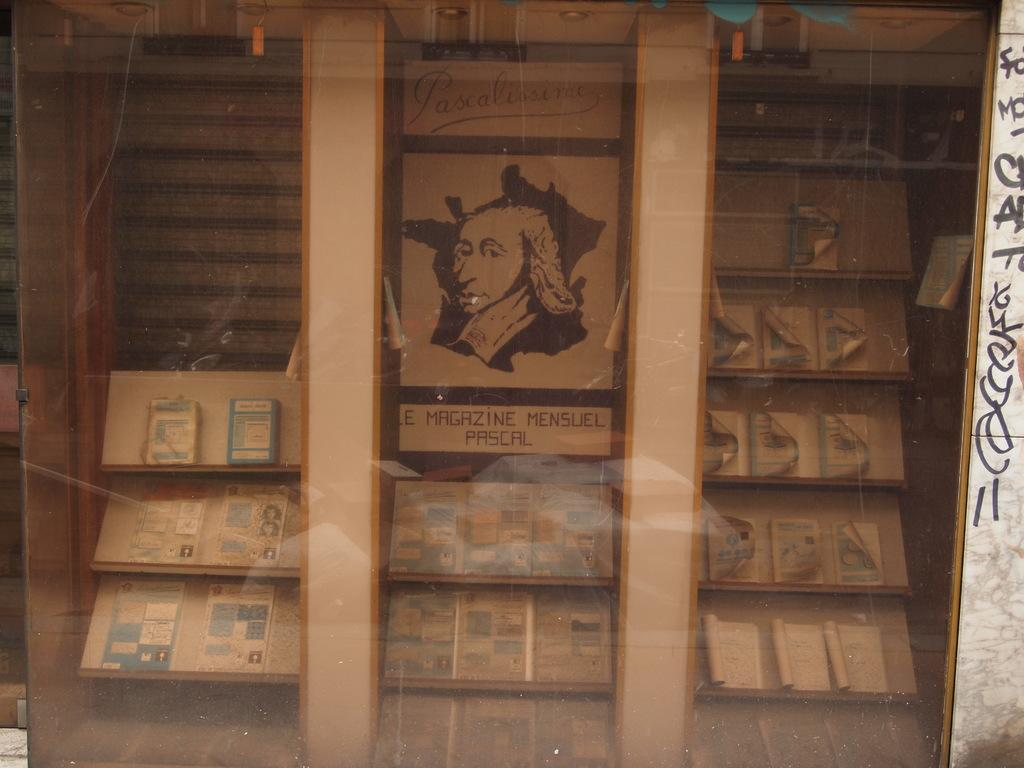What can be seen on the shelves in the image? There are objects on the shelves in the image. What is featured on the posters in the image? The posters in the image have text and images. What material is visible in the image? There is some glass visible in the image. Where is the text located in the image? The text is on the right side of the image. How does the image convey a sense of disgust? The image does not convey a sense of disgust; it features shelves, posters, and glass with text and objects. What type of toothbrush is visible in the image? There is no toothbrush present in the image. 